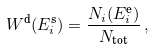<formula> <loc_0><loc_0><loc_500><loc_500>W ^ { \text {d} } ( E ^ { \text {s} } _ { i } ) = \frac { N _ { i } ( E ^ { \text {e} } _ { i } ) } { N _ { \text {tot} } } \, ,</formula> 